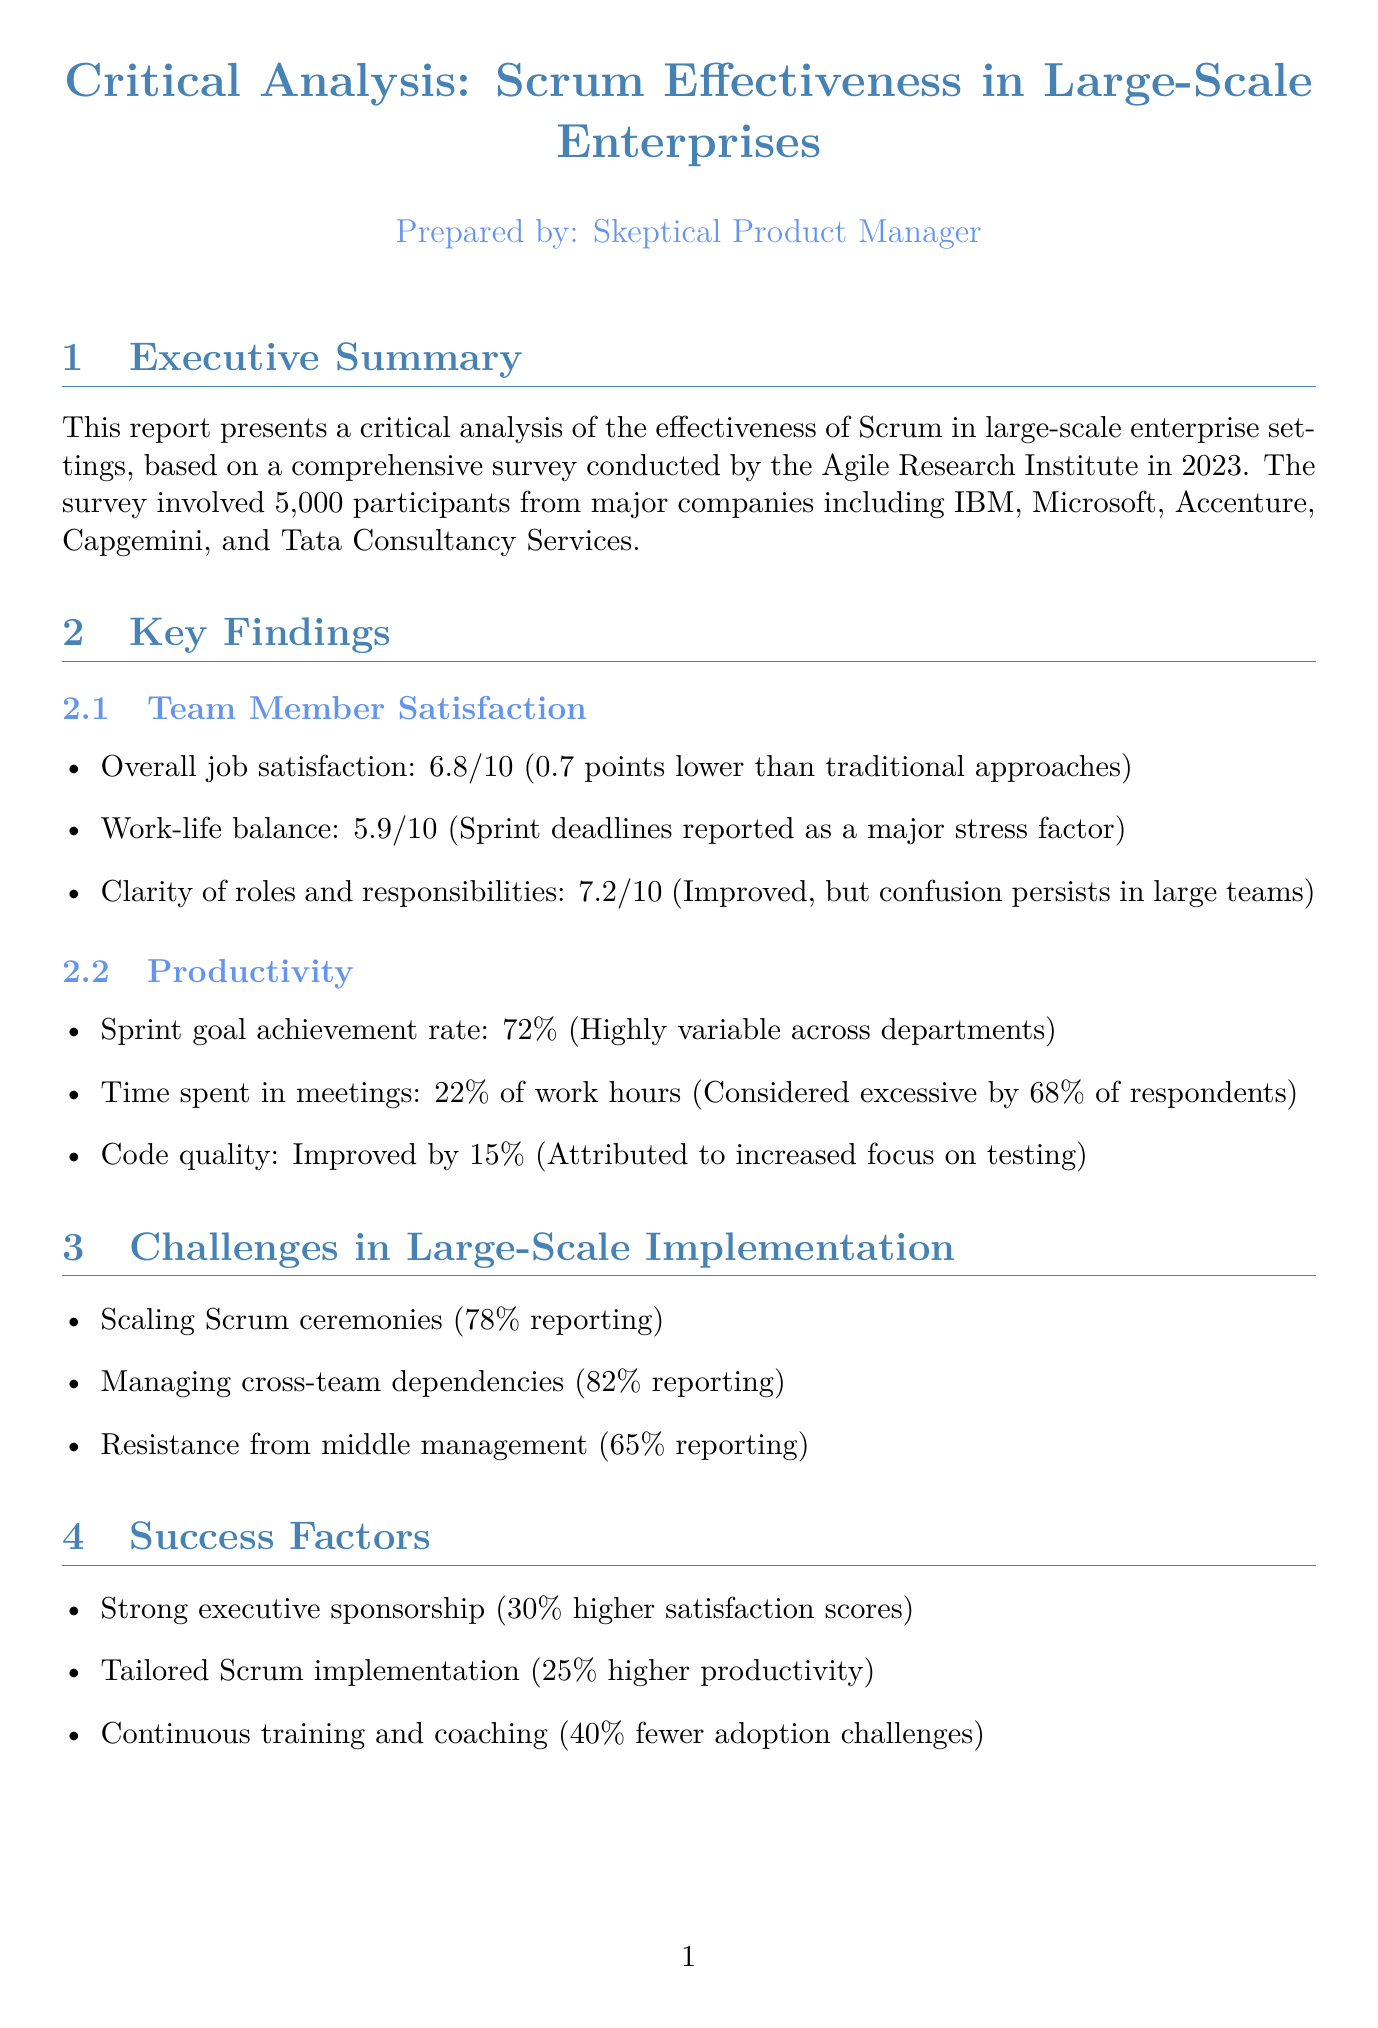what is the title of the survey? The title of the survey is mentioned in the document as "Scrum Effectiveness in Large-Scale Enterprises: Team Member Satisfaction and Productivity Survey."
Answer: Scrum Effectiveness in Large-Scale Enterprises: Team Member Satisfaction and Productivity Survey who conducted the survey? The organization conducting the survey is specified in the document as the "Agile Research Institute."
Answer: Agile Research Institute what was the overall job satisfaction score? The overall job satisfaction score reported in the findings is 6.8 out of 10.
Answer: 6.8 what percentage of respondents consider time spent in meetings excessive? The document states that 68% of respondents find the time spent in meetings excessive.
Answer: 68% what is one challenge identified for large-scale Scrum implementation? The document lists "Cross-team dependencies" as one of the challenges identified for large-scale Scrum implementation.
Answer: Cross-team dependencies which industry had the highest satisfaction score? According to the industry comparisons, the Healthcare industry had the highest satisfaction score of 7.1.
Answer: Healthcare what was the improvement in code quality attributed to increased testing? The document mentions that code quality improved by 15% attributed to an increased focus on testing within sprints.
Answer: 15% what factor contributed to 30% higher satisfaction scores? The document indicates that "Strong executive sponsorship" contributed to 30% higher satisfaction scores.
Answer: Strong executive sponsorship 